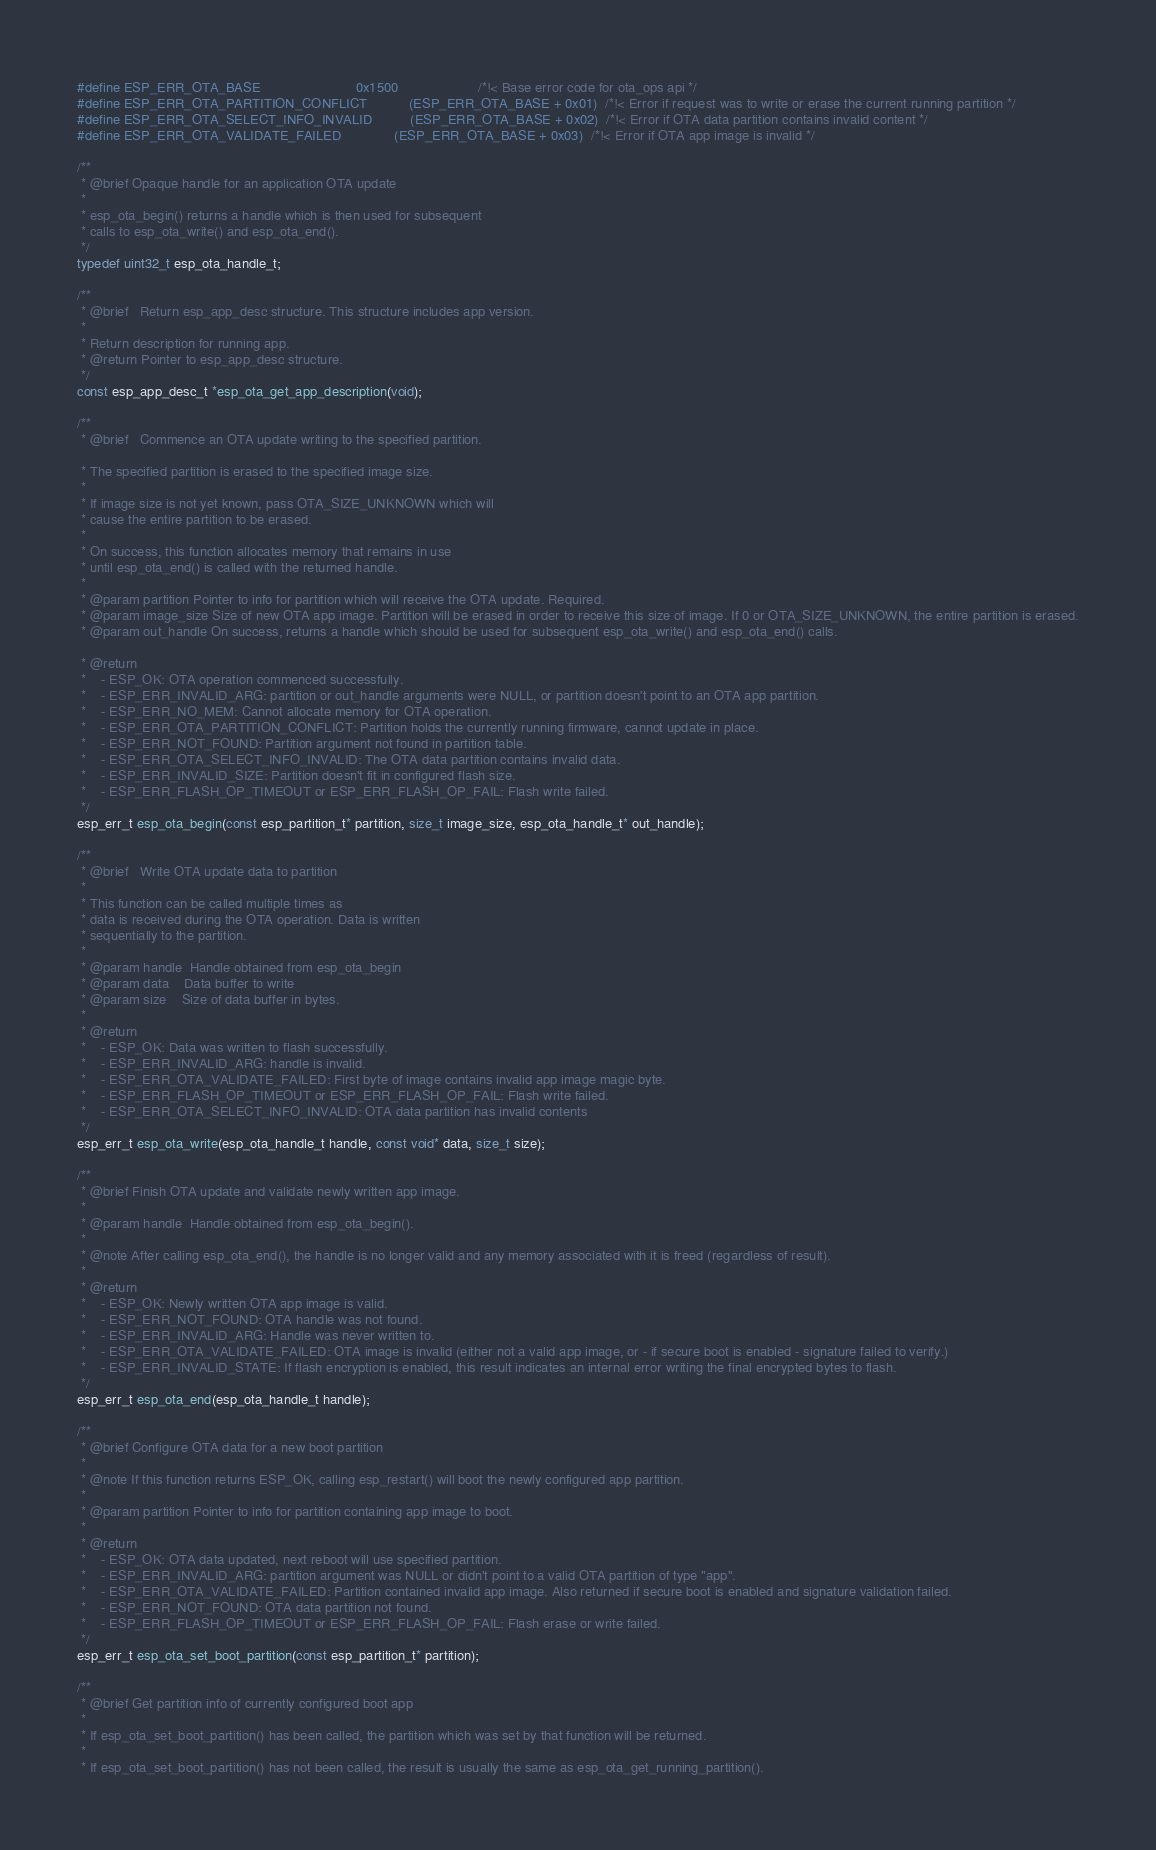Convert code to text. <code><loc_0><loc_0><loc_500><loc_500><_C_>#define ESP_ERR_OTA_BASE                         0x1500                     /*!< Base error code for ota_ops api */
#define ESP_ERR_OTA_PARTITION_CONFLICT           (ESP_ERR_OTA_BASE + 0x01)  /*!< Error if request was to write or erase the current running partition */
#define ESP_ERR_OTA_SELECT_INFO_INVALID          (ESP_ERR_OTA_BASE + 0x02)  /*!< Error if OTA data partition contains invalid content */
#define ESP_ERR_OTA_VALIDATE_FAILED              (ESP_ERR_OTA_BASE + 0x03)  /*!< Error if OTA app image is invalid */

/**
 * @brief Opaque handle for an application OTA update
 *
 * esp_ota_begin() returns a handle which is then used for subsequent
 * calls to esp_ota_write() and esp_ota_end().
 */
typedef uint32_t esp_ota_handle_t;

/**
 * @brief   Return esp_app_desc structure. This structure includes app version.
 * 
 * Return description for running app.
 * @return Pointer to esp_app_desc structure.
 */
const esp_app_desc_t *esp_ota_get_app_description(void);

/**
 * @brief   Commence an OTA update writing to the specified partition.

 * The specified partition is erased to the specified image size.
 *
 * If image size is not yet known, pass OTA_SIZE_UNKNOWN which will
 * cause the entire partition to be erased.
 *
 * On success, this function allocates memory that remains in use
 * until esp_ota_end() is called with the returned handle.
 *
 * @param partition Pointer to info for partition which will receive the OTA update. Required.
 * @param image_size Size of new OTA app image. Partition will be erased in order to receive this size of image. If 0 or OTA_SIZE_UNKNOWN, the entire partition is erased.
 * @param out_handle On success, returns a handle which should be used for subsequent esp_ota_write() and esp_ota_end() calls.

 * @return
 *    - ESP_OK: OTA operation commenced successfully.
 *    - ESP_ERR_INVALID_ARG: partition or out_handle arguments were NULL, or partition doesn't point to an OTA app partition.
 *    - ESP_ERR_NO_MEM: Cannot allocate memory for OTA operation.
 *    - ESP_ERR_OTA_PARTITION_CONFLICT: Partition holds the currently running firmware, cannot update in place.
 *    - ESP_ERR_NOT_FOUND: Partition argument not found in partition table.
 *    - ESP_ERR_OTA_SELECT_INFO_INVALID: The OTA data partition contains invalid data.
 *    - ESP_ERR_INVALID_SIZE: Partition doesn't fit in configured flash size.
 *    - ESP_ERR_FLASH_OP_TIMEOUT or ESP_ERR_FLASH_OP_FAIL: Flash write failed.
 */
esp_err_t esp_ota_begin(const esp_partition_t* partition, size_t image_size, esp_ota_handle_t* out_handle);

/**
 * @brief   Write OTA update data to partition
 *
 * This function can be called multiple times as
 * data is received during the OTA operation. Data is written
 * sequentially to the partition.
 *
 * @param handle  Handle obtained from esp_ota_begin
 * @param data    Data buffer to write
 * @param size    Size of data buffer in bytes.
 *
 * @return
 *    - ESP_OK: Data was written to flash successfully.
 *    - ESP_ERR_INVALID_ARG: handle is invalid.
 *    - ESP_ERR_OTA_VALIDATE_FAILED: First byte of image contains invalid app image magic byte.
 *    - ESP_ERR_FLASH_OP_TIMEOUT or ESP_ERR_FLASH_OP_FAIL: Flash write failed.
 *    - ESP_ERR_OTA_SELECT_INFO_INVALID: OTA data partition has invalid contents
 */
esp_err_t esp_ota_write(esp_ota_handle_t handle, const void* data, size_t size);

/**
 * @brief Finish OTA update and validate newly written app image.
 *
 * @param handle  Handle obtained from esp_ota_begin().
 *
 * @note After calling esp_ota_end(), the handle is no longer valid and any memory associated with it is freed (regardless of result).
 *
 * @return
 *    - ESP_OK: Newly written OTA app image is valid.
 *    - ESP_ERR_NOT_FOUND: OTA handle was not found.
 *    - ESP_ERR_INVALID_ARG: Handle was never written to.
 *    - ESP_ERR_OTA_VALIDATE_FAILED: OTA image is invalid (either not a valid app image, or - if secure boot is enabled - signature failed to verify.)
 *    - ESP_ERR_INVALID_STATE: If flash encryption is enabled, this result indicates an internal error writing the final encrypted bytes to flash.
 */
esp_err_t esp_ota_end(esp_ota_handle_t handle);

/**
 * @brief Configure OTA data for a new boot partition
 *
 * @note If this function returns ESP_OK, calling esp_restart() will boot the newly configured app partition.
 *
 * @param partition Pointer to info for partition containing app image to boot.
 *
 * @return
 *    - ESP_OK: OTA data updated, next reboot will use specified partition.
 *    - ESP_ERR_INVALID_ARG: partition argument was NULL or didn't point to a valid OTA partition of type "app".
 *    - ESP_ERR_OTA_VALIDATE_FAILED: Partition contained invalid app image. Also returned if secure boot is enabled and signature validation failed.
 *    - ESP_ERR_NOT_FOUND: OTA data partition not found.
 *    - ESP_ERR_FLASH_OP_TIMEOUT or ESP_ERR_FLASH_OP_FAIL: Flash erase or write failed.
 */
esp_err_t esp_ota_set_boot_partition(const esp_partition_t* partition);

/**
 * @brief Get partition info of currently configured boot app
 *
 * If esp_ota_set_boot_partition() has been called, the partition which was set by that function will be returned.
 *
 * If esp_ota_set_boot_partition() has not been called, the result is usually the same as esp_ota_get_running_partition().</code> 